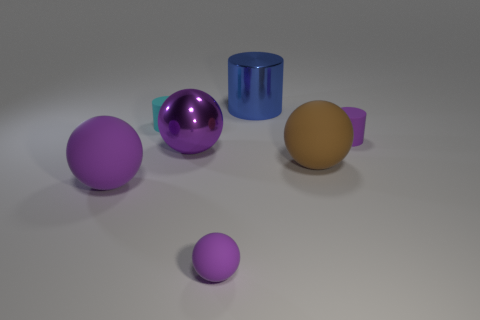Are there any cyan rubber objects that have the same size as the brown rubber thing?
Provide a short and direct response. No. What is the material of the brown thing that is the same size as the metal cylinder?
Give a very brief answer. Rubber. What number of things are small matte things behind the large purple matte ball or purple objects that are behind the large brown ball?
Give a very brief answer. 3. Are there any yellow objects of the same shape as the cyan matte thing?
Offer a very short reply. No. What is the material of the cylinder that is the same color as the tiny ball?
Provide a succinct answer. Rubber. What number of matte objects are purple cubes or small balls?
Your answer should be compact. 1. What shape is the large purple metallic thing?
Make the answer very short. Sphere. How many gray objects are made of the same material as the cyan cylinder?
Offer a very short reply. 0. There is a thing that is the same material as the big cylinder; what is its color?
Your answer should be compact. Purple. There is a purple sphere behind the brown matte sphere; does it have the same size as the big brown sphere?
Offer a terse response. Yes. 